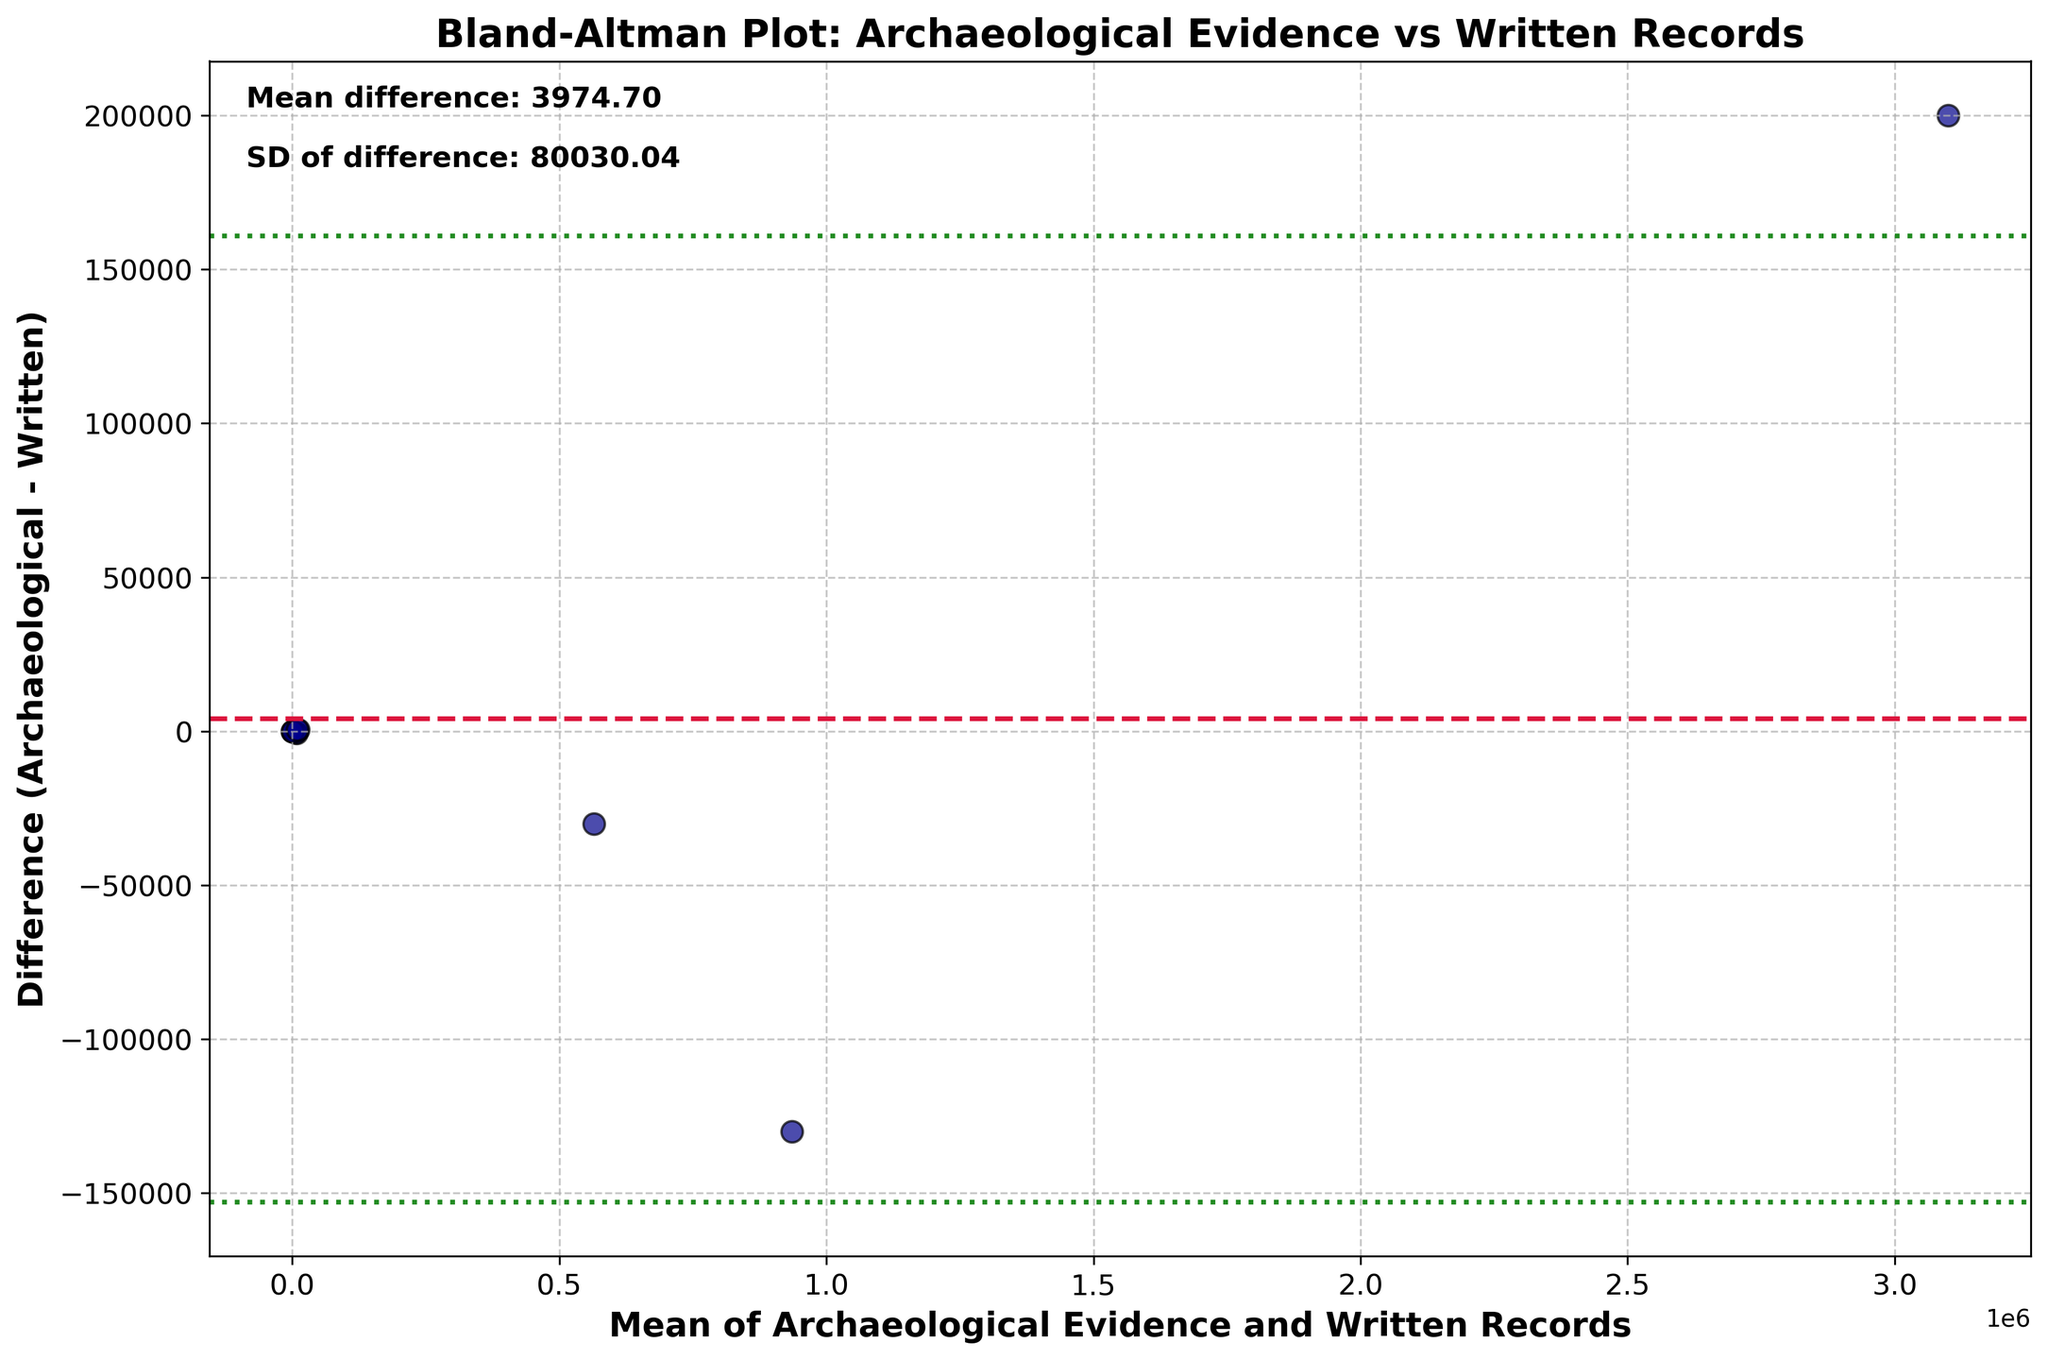What is the title of the plot? The title is the large text at the top of the plot. Titles usually describe the content and purpose of the plot.
Answer: Bland-Altman Plot: Archaeological Evidence vs Written Records What does the y-axis represent? The y-axis label is vertical text along the side of the figure. It states what the y-axis values are measuring.
Answer: Difference (Archaeological - Written) How many data points are plotted in the figure? The number of data points is equal to the number of scatter points present in the plot, each corresponding to one pair of values from the dataset.
Answer: 10 What color are the scatter points? The scatter points' color can be visually identified. All points are the same specific color used in the plot.
Answer: Dark blue What does the red dashed line in the plot signify? In a Bland-Altman plot, the red dashed line typically represents the mean difference between the two sets of measurements.
Answer: Mean difference What is the mean difference between the two methods of measurement? The mean difference is labeled directly on the plot, often near the y-axis. It shows the average difference between archaeological evidence and written records.
Answer: 8.0 What is the purpose of the two green dotted lines in the plot? In a Bland-Altman plot, the green dotted lines indicate the limits of agreement, which are calculated as mean difference ± 1.96 times the standard deviation of differences.
Answer: Limits of agreement What are the values of the limits of agreement? The values for the limits of agreement are positioned where the green dotted lines intersect the y-axis.
Answer: -1445.36 and 1461.36 Which data point shows the greatest positive difference and what values correspond to it? The greatest positive difference is at the highest point above the x-axis. You can identify the x (mean) and y (difference) coordinates of this point to find the related values.
Answer: Grain production in the Mayan civilization; 565000 (Grain production) and 30000 (Difference) 